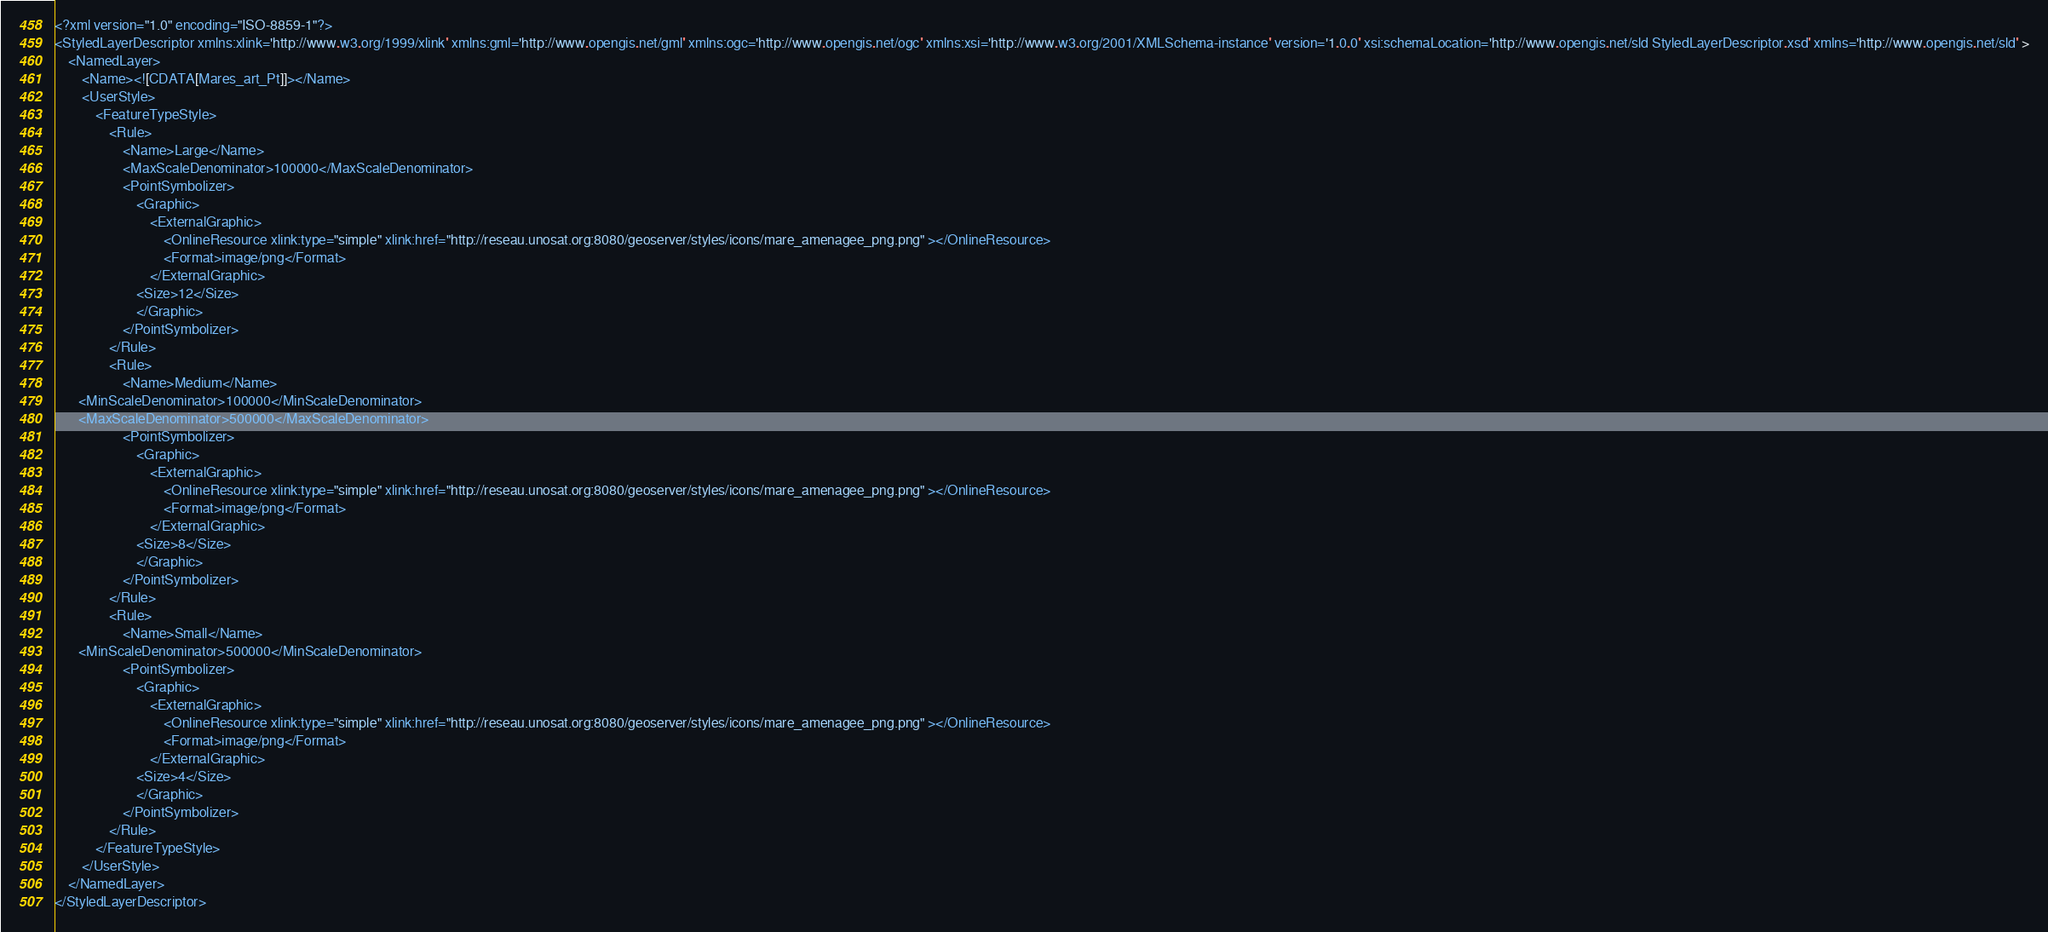<code> <loc_0><loc_0><loc_500><loc_500><_Scheme_><?xml version="1.0" encoding="ISO-8859-1"?>
<StyledLayerDescriptor xmlns:xlink='http://www.w3.org/1999/xlink' xmlns:gml='http://www.opengis.net/gml' xmlns:ogc='http://www.opengis.net/ogc' xmlns:xsi='http://www.w3.org/2001/XMLSchema-instance' version='1.0.0' xsi:schemaLocation='http://www.opengis.net/sld StyledLayerDescriptor.xsd' xmlns='http://www.opengis.net/sld' >
	<NamedLayer>
		<Name><![CDATA[Mares_art_Pt]]></Name>
		<UserStyle>
			<FeatureTypeStyle>
				<Rule>
                    <Name>Large</Name>
					<MaxScaleDenominator>100000</MaxScaleDenominator>
					<PointSymbolizer>
						<Graphic>
							<ExternalGraphic>
								<OnlineResource xlink:type="simple" xlink:href="http://reseau.unosat.org:8080/geoserver/styles/icons/mare_amenagee_png.png" ></OnlineResource>
								<Format>image/png</Format>
							</ExternalGraphic>
                        <Size>12</Size>
						</Graphic>
					</PointSymbolizer>
				</Rule>
				<Rule>
                    <Name>Medium</Name>
       <MinScaleDenominator>100000</MinScaleDenominator>
       <MaxScaleDenominator>500000</MaxScaleDenominator>
					<PointSymbolizer>
						<Graphic>
							<ExternalGraphic>
								<OnlineResource xlink:type="simple" xlink:href="http://reseau.unosat.org:8080/geoserver/styles/icons/mare_amenagee_png.png" ></OnlineResource>
								<Format>image/png</Format>
							</ExternalGraphic>
                        <Size>8</Size>
						</Graphic>
					</PointSymbolizer>
				</Rule>
				<Rule>
                    <Name>Small</Name>
       <MinScaleDenominator>500000</MinScaleDenominator>
					<PointSymbolizer>
						<Graphic>
							<ExternalGraphic>
								<OnlineResource xlink:type="simple" xlink:href="http://reseau.unosat.org:8080/geoserver/styles/icons/mare_amenagee_png.png" ></OnlineResource>
								<Format>image/png</Format>
							</ExternalGraphic>
                        <Size>4</Size>
						</Graphic>
					</PointSymbolizer>
				</Rule>
			</FeatureTypeStyle>
		</UserStyle>
	</NamedLayer>
</StyledLayerDescriptor></code> 